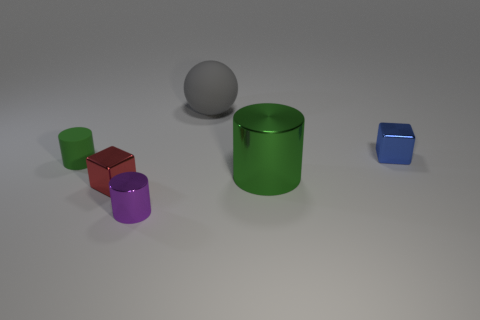Subtract all green rubber cylinders. How many cylinders are left? 2 Add 3 big yellow metal cylinders. How many objects exist? 9 Subtract all purple cylinders. How many cylinders are left? 2 Subtract all blocks. How many objects are left? 4 Subtract 2 cubes. How many cubes are left? 0 Subtract all large gray objects. Subtract all large brown metal spheres. How many objects are left? 5 Add 2 large gray things. How many large gray things are left? 3 Add 2 purple metallic objects. How many purple metallic objects exist? 3 Subtract 1 red blocks. How many objects are left? 5 Subtract all gray cylinders. Subtract all yellow spheres. How many cylinders are left? 3 